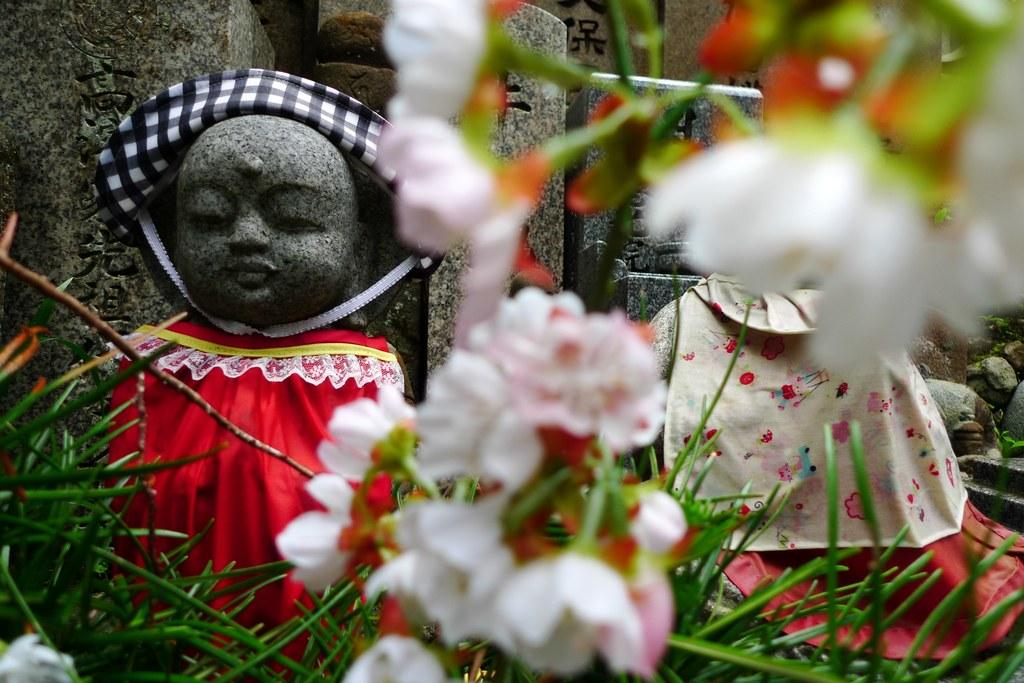What type of objects are depicted in the image with clothes? There are sculptures with clothes in the image. What kind of floral elements are present in the image? There are white flowers in the image. Where are the flowers located in relation to the sculptures? The flowers are on the grass at the bottom of the image. What type of lunch is being served to the toad in the image? There is no toad or lunch present in the image. 